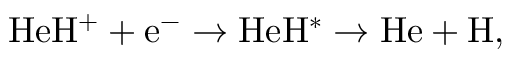<formula> <loc_0><loc_0><loc_500><loc_500>H e H ^ { + } + e ^ { - } \rightarrow H e H ^ { * } \rightarrow H e + H ,</formula> 